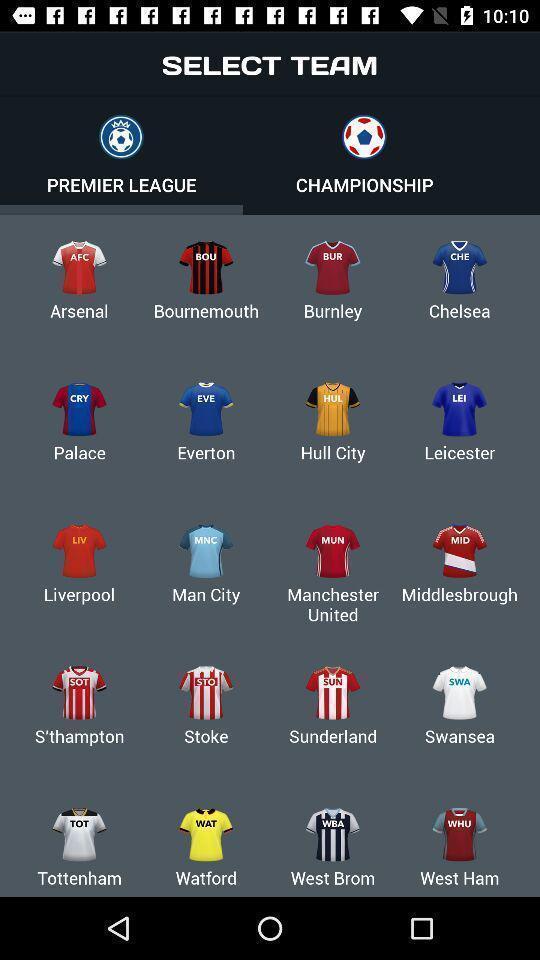Tell me what you see in this picture. Screen asking to select a team for premier league. 